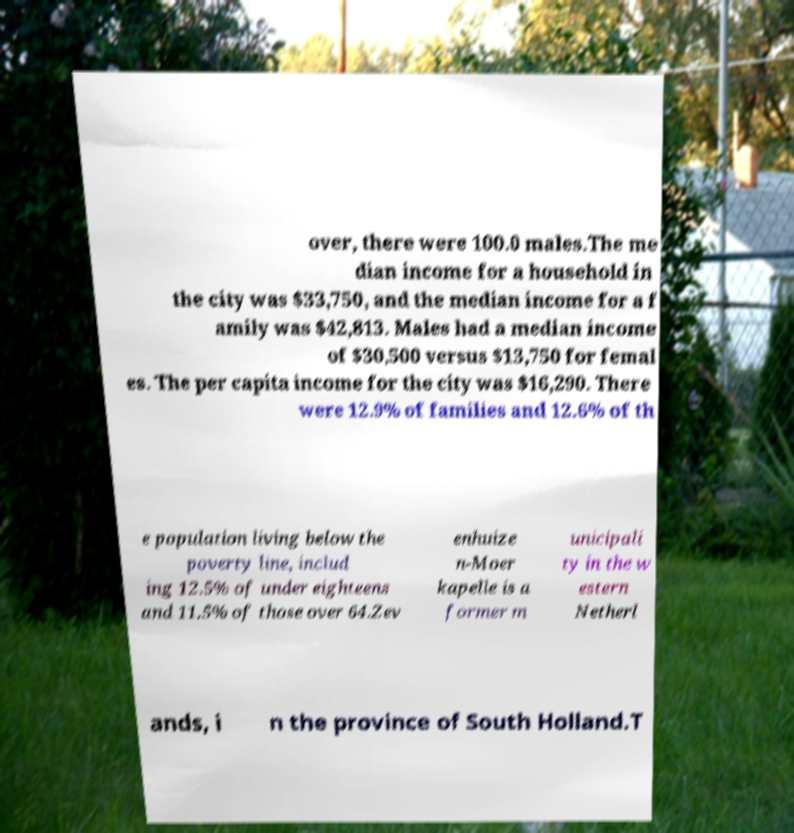There's text embedded in this image that I need extracted. Can you transcribe it verbatim? over, there were 100.0 males.The me dian income for a household in the city was $33,750, and the median income for a f amily was $42,813. Males had a median income of $30,500 versus $13,750 for femal es. The per capita income for the city was $16,290. There were 12.9% of families and 12.6% of th e population living below the poverty line, includ ing 12.5% of under eighteens and 11.5% of those over 64.Zev enhuize n-Moer kapelle is a former m unicipali ty in the w estern Netherl ands, i n the province of South Holland.T 